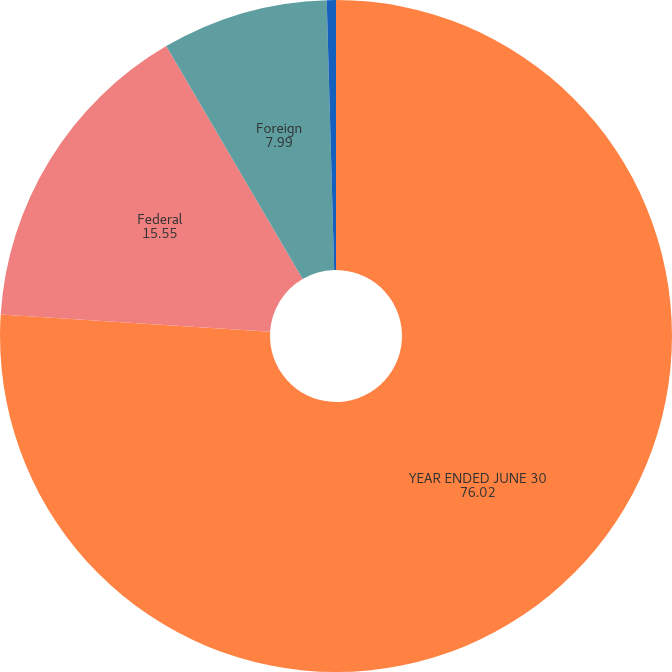Convert chart. <chart><loc_0><loc_0><loc_500><loc_500><pie_chart><fcel>YEAR ENDED JUNE 30<fcel>Federal<fcel>Foreign<fcel>State and local<nl><fcel>76.02%<fcel>15.55%<fcel>7.99%<fcel>0.44%<nl></chart> 